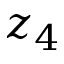Convert formula to latex. <formula><loc_0><loc_0><loc_500><loc_500>z _ { 4 }</formula> 